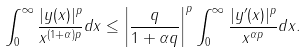<formula> <loc_0><loc_0><loc_500><loc_500>\int ^ { \infty } _ { 0 } \frac { | y ( x ) | ^ { p } } { x ^ { ( 1 + \alpha ) p } } d x \leq \left | \frac { q } { 1 + \alpha q } \right | ^ { p } \int ^ { \infty } _ { 0 } \frac { | y ^ { \prime } ( x ) | ^ { p } } { x ^ { \alpha p } } d x .</formula> 